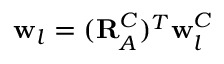<formula> <loc_0><loc_0><loc_500><loc_500>w _ { l } = ( R _ { A } ^ { C } ) ^ { T } w _ { l } ^ { C }</formula> 